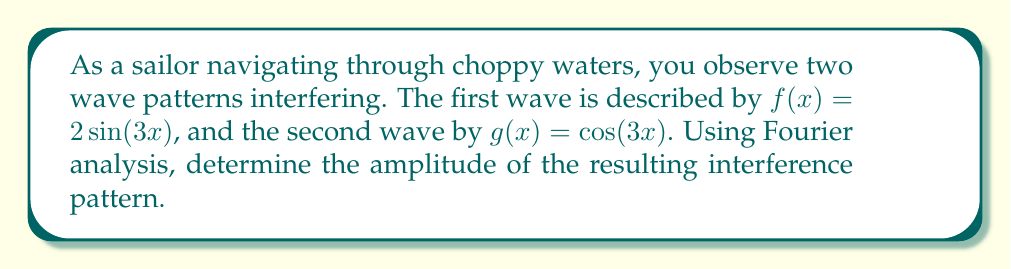Can you answer this question? Let's approach this step-by-step:

1) The resulting interference pattern is the sum of the two waves:
   $h(x) = f(x) + g(x) = 2\sin(3x) + \cos(3x)$

2) To find the amplitude using Fourier analysis, we need to express this in the form:
   $A\cos(3x - \phi)$, where $A$ is the amplitude and $\phi$ is the phase shift.

3) We can use the trigonometric identity:
   $a\sin\theta + b\cos\theta = \sqrt{a^2 + b^2}\cos(\theta - \arctan(\frac{a}{b}))$

4) In our case, $a = 2$, $b = 1$, and $\theta = 3x$. Let's substitute:
   $h(x) = \sqrt{2^2 + 1^2}\cos(3x - \arctan(2))$

5) Simplify:
   $h(x) = \sqrt{5}\cos(3x - \arctan(2))$

6) The amplitude is the coefficient of the cosine term, which is $\sqrt{5}$.

This approach uses Fourier analysis principles by expressing the sum of sinusoidal functions as a single sinusoid with a new amplitude and phase shift.
Answer: $\sqrt{5}$ 